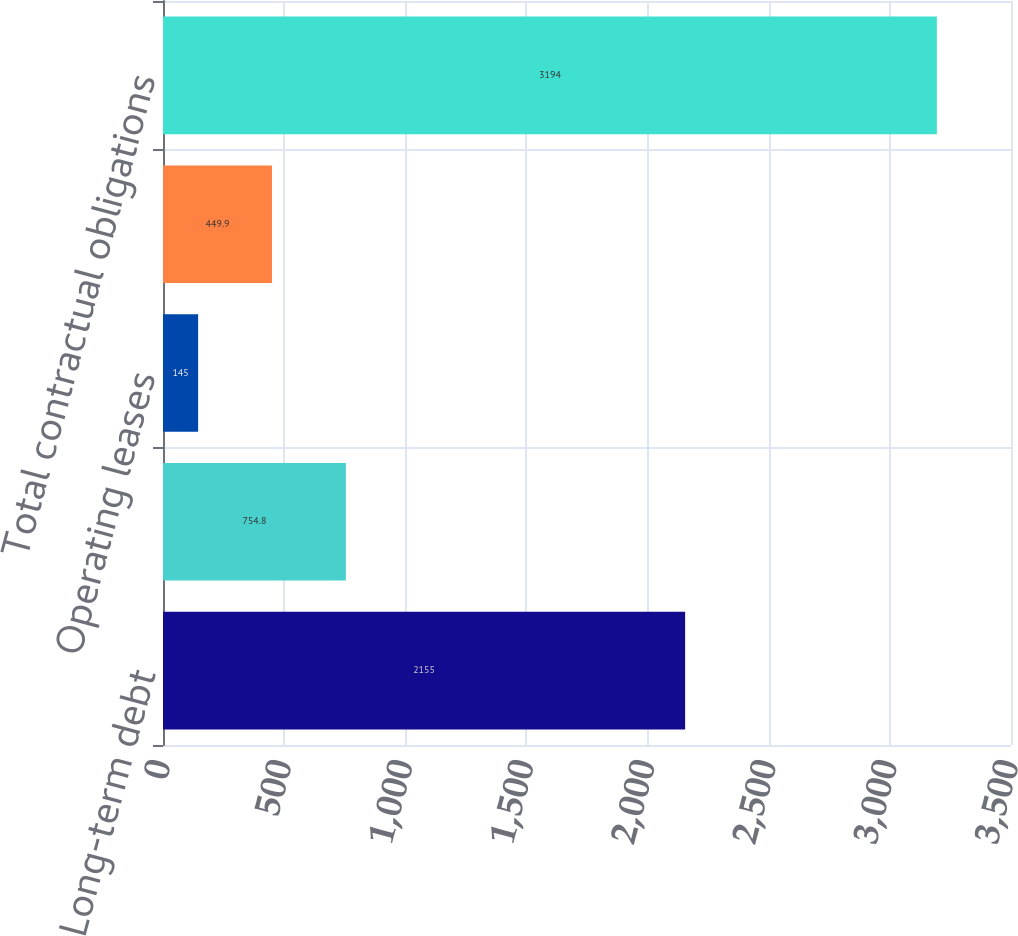Convert chart to OTSL. <chart><loc_0><loc_0><loc_500><loc_500><bar_chart><fcel>Long-term debt<fcel>Interest payments on long-term<fcel>Operating leases<fcel>Unconditional purchase<fcel>Total contractual obligations<nl><fcel>2155<fcel>754.8<fcel>145<fcel>449.9<fcel>3194<nl></chart> 